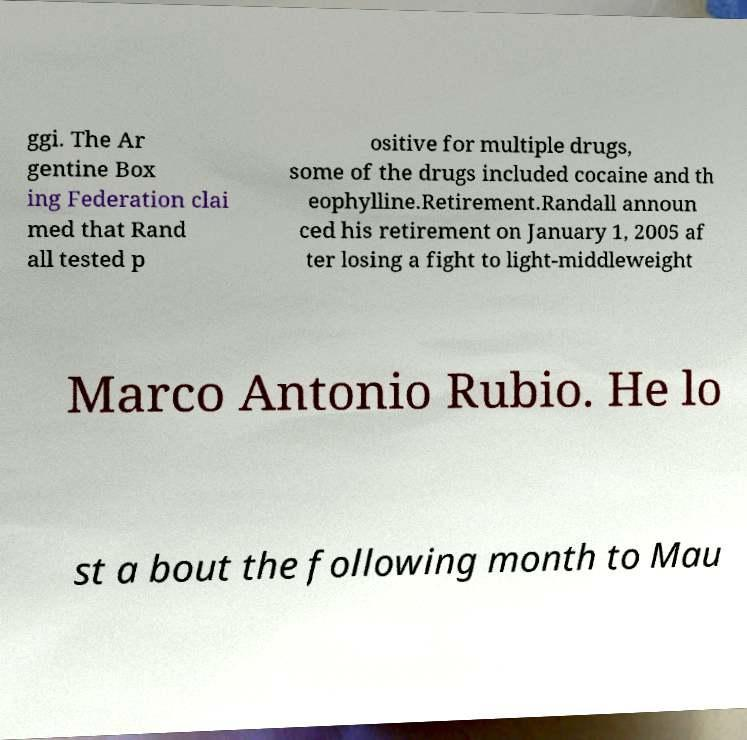Could you extract and type out the text from this image? ggi. The Ar gentine Box ing Federation clai med that Rand all tested p ositive for multiple drugs, some of the drugs included cocaine and th eophylline.Retirement.Randall announ ced his retirement on January 1, 2005 af ter losing a fight to light-middleweight Marco Antonio Rubio. He lo st a bout the following month to Mau 